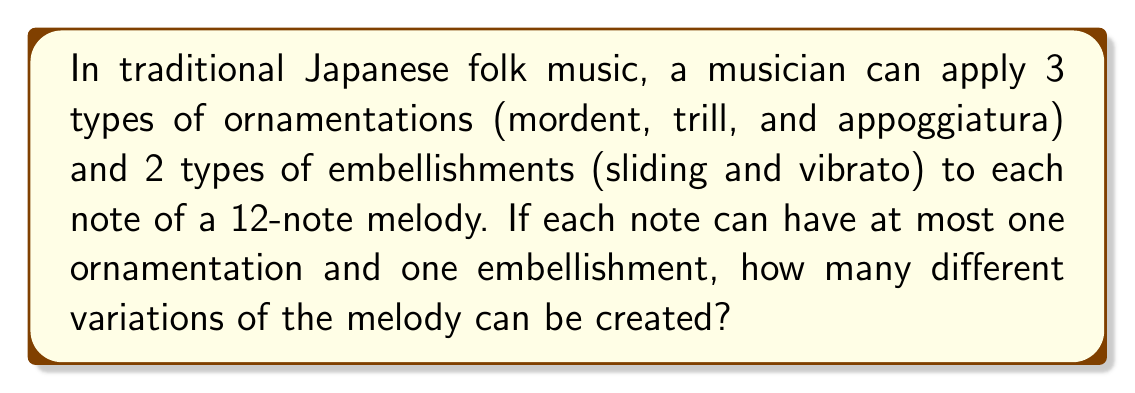Show me your answer to this math problem. Let's approach this step-by-step:

1) For each note, we have the following options:
   - 3 types of ornamentations (mordent, trill, appoggiatura)
   - 2 types of embellishments (sliding, vibrato)
   - The option to use no ornamentation
   - The option to use no embellishment

2) This means for each note, we have:
   - 4 ornamentation options (3 types + no ornamentation)
   - 3 embellishment options (2 types + no embellishment)

3) For a single note, the total number of combinations is:
   $4 \times 3 = 12$

4) Since we have 12 notes in the melody, and each note can be varied independently, we use the multiplication principle.

5) The total number of variations is:
   $12^{12}$

6) Calculating this:
   $$12^{12} = 8,916,100,448,256$$

Therefore, there are 8,916,100,448,256 different variations of the melody that can be created using these ornamentations and embellishments.
Answer: $12^{12} = 8,916,100,448,256$ 